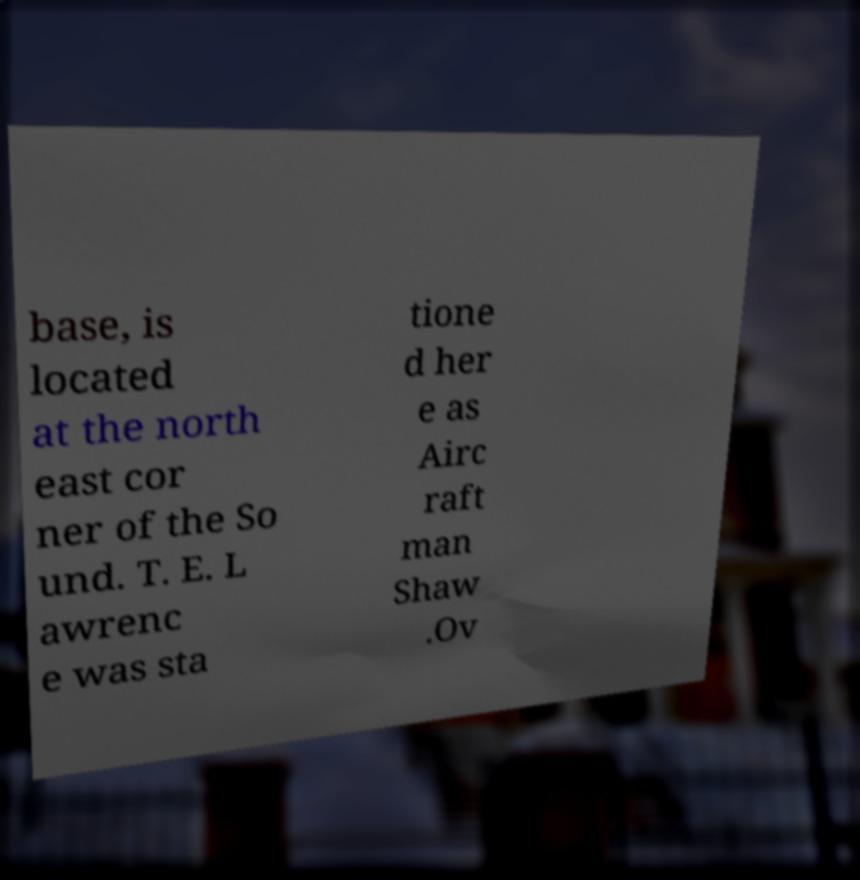Please identify and transcribe the text found in this image. base, is located at the north east cor ner of the So und. T. E. L awrenc e was sta tione d her e as Airc raft man Shaw .Ov 